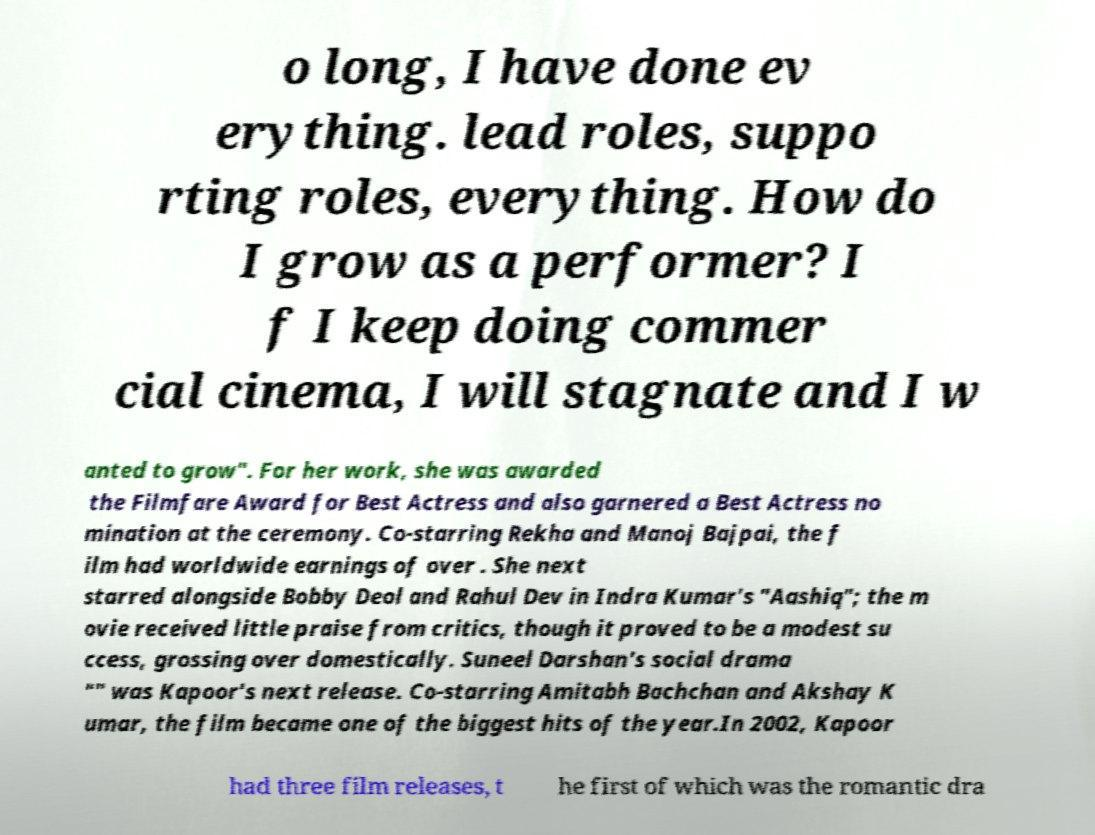What messages or text are displayed in this image? I need them in a readable, typed format. o long, I have done ev erything. lead roles, suppo rting roles, everything. How do I grow as a performer? I f I keep doing commer cial cinema, I will stagnate and I w anted to grow". For her work, she was awarded the Filmfare Award for Best Actress and also garnered a Best Actress no mination at the ceremony. Co-starring Rekha and Manoj Bajpai, the f ilm had worldwide earnings of over . She next starred alongside Bobby Deol and Rahul Dev in Indra Kumar's "Aashiq"; the m ovie received little praise from critics, though it proved to be a modest su ccess, grossing over domestically. Suneel Darshan's social drama "" was Kapoor's next release. Co-starring Amitabh Bachchan and Akshay K umar, the film became one of the biggest hits of the year.In 2002, Kapoor had three film releases, t he first of which was the romantic dra 